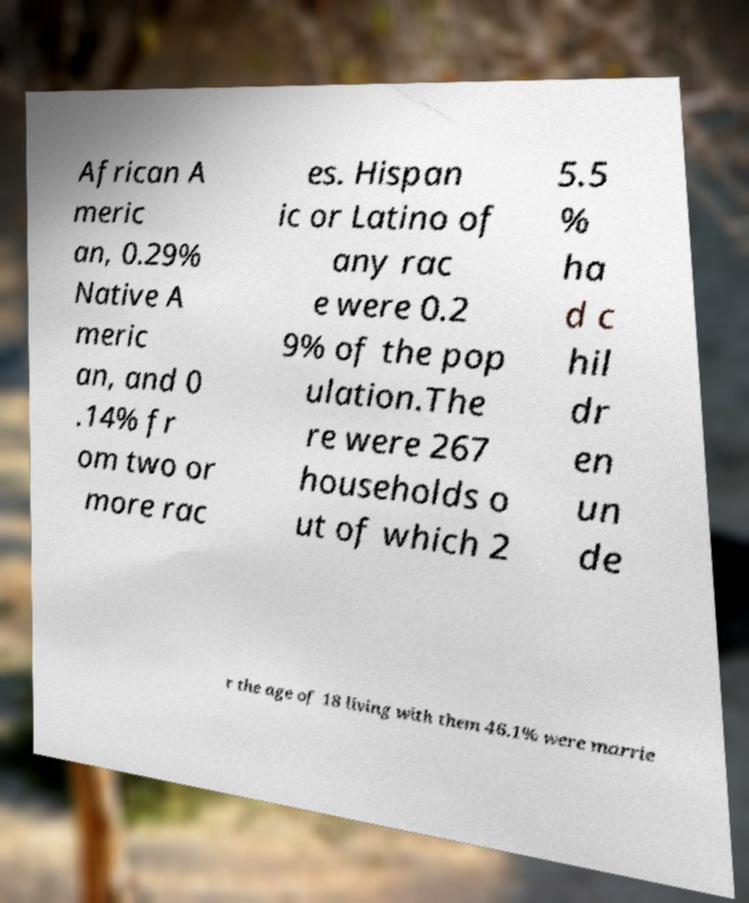What messages or text are displayed in this image? I need them in a readable, typed format. African A meric an, 0.29% Native A meric an, and 0 .14% fr om two or more rac es. Hispan ic or Latino of any rac e were 0.2 9% of the pop ulation.The re were 267 households o ut of which 2 5.5 % ha d c hil dr en un de r the age of 18 living with them 46.1% were marrie 